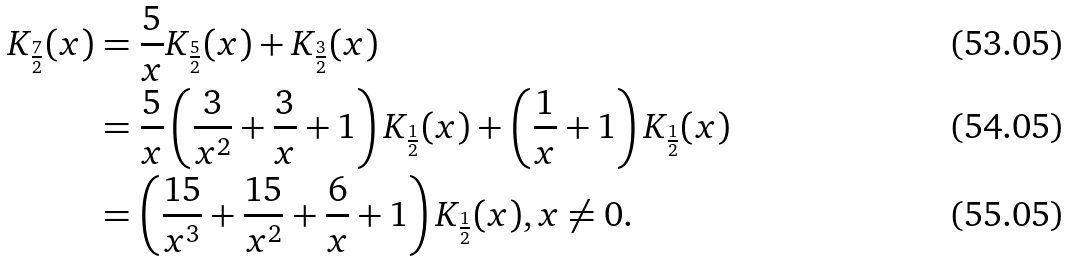Convert formula to latex. <formula><loc_0><loc_0><loc_500><loc_500>K _ { \frac { 7 } { 2 } } ( x ) & = \frac { 5 } { x } K _ { \frac { 5 } { 2 } } ( x ) + K _ { \frac { 3 } { 2 } } ( x ) \\ & = \frac { 5 } { x } \left ( \frac { 3 } { x ^ { 2 } } + \frac { 3 } { x } + 1 \right ) K _ { \frac { 1 } { 2 } } ( x ) + \left ( \frac { 1 } { x } + 1 \right ) K _ { \frac { 1 } { 2 } } ( x ) \\ & = \left ( \frac { 1 5 } { x ^ { 3 } } + \frac { 1 5 } { x ^ { 2 } } + \frac { 6 } { x } + 1 \right ) K _ { \frac { 1 } { 2 } } ( x ) , x \neq 0 .</formula> 